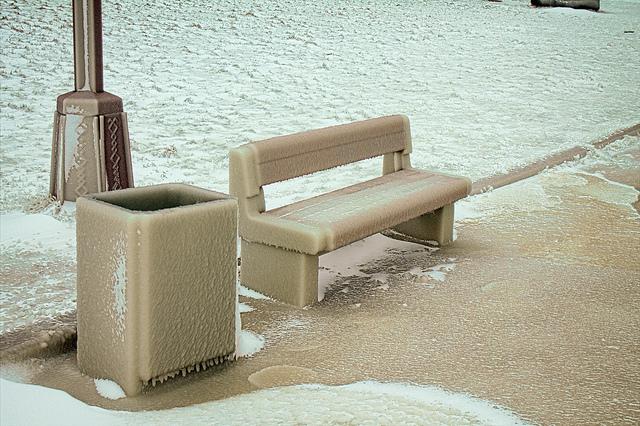Would you need to dress warmly to be outside?
Concise answer only. Yes. Would most people want to sit on this bench if they were wearing a swimsuit?
Give a very brief answer. No. What substance could be sprinkled on the ground to make it safer to walk here?
Keep it brief. Salt. 